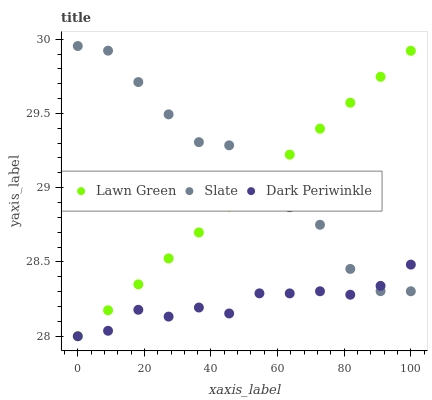Does Dark Periwinkle have the minimum area under the curve?
Answer yes or no. Yes. Does Slate have the maximum area under the curve?
Answer yes or no. Yes. Does Slate have the minimum area under the curve?
Answer yes or no. No. Does Dark Periwinkle have the maximum area under the curve?
Answer yes or no. No. Is Lawn Green the smoothest?
Answer yes or no. Yes. Is Slate the roughest?
Answer yes or no. Yes. Is Dark Periwinkle the smoothest?
Answer yes or no. No. Is Dark Periwinkle the roughest?
Answer yes or no. No. Does Lawn Green have the lowest value?
Answer yes or no. Yes. Does Slate have the lowest value?
Answer yes or no. No. Does Slate have the highest value?
Answer yes or no. Yes. Does Dark Periwinkle have the highest value?
Answer yes or no. No. Does Slate intersect Dark Periwinkle?
Answer yes or no. Yes. Is Slate less than Dark Periwinkle?
Answer yes or no. No. Is Slate greater than Dark Periwinkle?
Answer yes or no. No. 